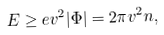Convert formula to latex. <formula><loc_0><loc_0><loc_500><loc_500>E \geq e v ^ { 2 } | \Phi | = 2 \pi v ^ { 2 } n ,</formula> 